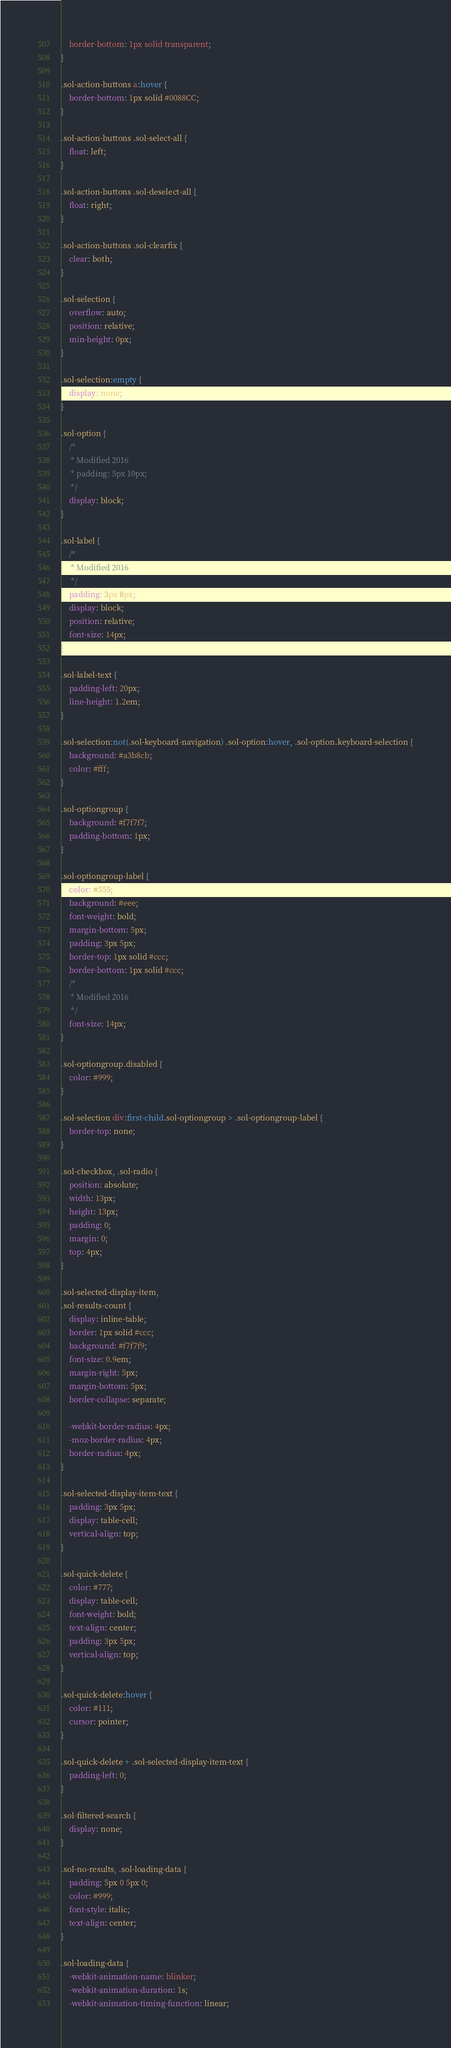Convert code to text. <code><loc_0><loc_0><loc_500><loc_500><_CSS_>    border-bottom: 1px solid transparent;
}

.sol-action-buttons a:hover {
    border-bottom: 1px solid #0088CC;
}

.sol-action-buttons .sol-select-all {
    float: left;
}

.sol-action-buttons .sol-deselect-all {
    float: right;
}

.sol-action-buttons .sol-clearfix {
    clear: both;
}

.sol-selection {
    overflow: auto;
    position: relative;
    min-height: 0px;
}

.sol-selection:empty {
    display: none;
}

.sol-option {
    /*
     * Modified 2016
     * padding: 5px 10px;
     */
    display: block;
}

.sol-label {
    /*
     * Modified 2016
     */
    padding: 3px 8px;
    display: block;
    position: relative;
    font-size: 14px;
}

.sol-label-text {
    padding-left: 20px;
    line-height: 1.2em;
}

.sol-selection:not(.sol-keyboard-navigation) .sol-option:hover, .sol-option.keyboard-selection {
    background: #a3b8cb;
    color: #fff;
}

.sol-optiongroup {
    background: #f7f7f7;
    padding-bottom: 1px;
}

.sol-optiongroup-label {
    color: #555;
    background: #eee;
    font-weight: bold;
    margin-bottom: 5px;
    padding: 3px 5px;
    border-top: 1px solid #ccc;
    border-bottom: 1px solid #ccc;
    /*
     * Modified 2016
     */
    font-size: 14px;
}

.sol-optiongroup.disabled {
    color: #999;
}

.sol-selection div:first-child.sol-optiongroup > .sol-optiongroup-label {
    border-top: none;
}

.sol-checkbox, .sol-radio {
    position: absolute;
    width: 13px;
    height: 13px;
    padding: 0;
    margin: 0;
    top: 4px;
}

.sol-selected-display-item,
.sol-results-count {
    display: inline-table;
    border: 1px solid #ccc;
    background: #f7f7f9;
    font-size: 0.9em;
    margin-right: 5px;
    margin-bottom: 5px;
    border-collapse: separate;

    -webkit-border-radius: 4px;
    -moz-border-radius: 4px;
    border-radius: 4px;
}

.sol-selected-display-item-text {
    padding: 3px 5px;
    display: table-cell;
    vertical-align: top;
}

.sol-quick-delete {
    color: #777;
    display: table-cell;
    font-weight: bold;
    text-align: center;
    padding: 3px 5px;
    vertical-align: top;
}

.sol-quick-delete:hover {
    color: #111;
    cursor: pointer;
}

.sol-quick-delete + .sol-selected-display-item-text {
    padding-left: 0;
}

.sol-filtered-search {
    display: none;
}

.sol-no-results, .sol-loading-data {
    padding: 5px 0 5px 0;
    color: #999;
    font-style: italic;
    text-align: center;
}

.sol-loading-data {
    -webkit-animation-name: blinker;
    -webkit-animation-duration: 1s;
    -webkit-animation-timing-function: linear;</code> 